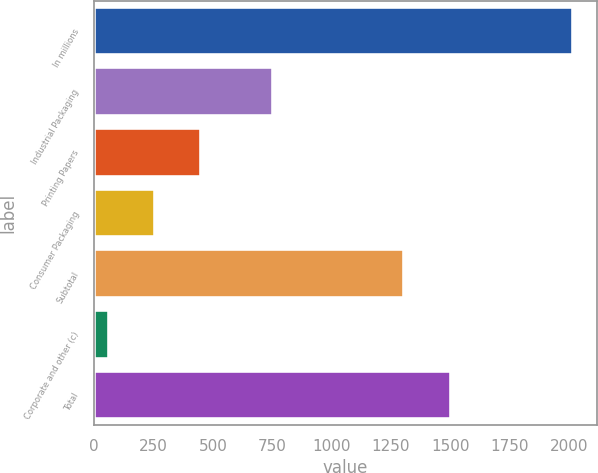<chart> <loc_0><loc_0><loc_500><loc_500><bar_chart><fcel>In millions<fcel>Industrial Packaging<fcel>Printing Papers<fcel>Consumer Packaging<fcel>Subtotal<fcel>Corporate and other (c)<fcel>Total<nl><fcel>2014<fcel>754<fcel>451.6<fcel>256.3<fcel>1305<fcel>61<fcel>1500.3<nl></chart> 